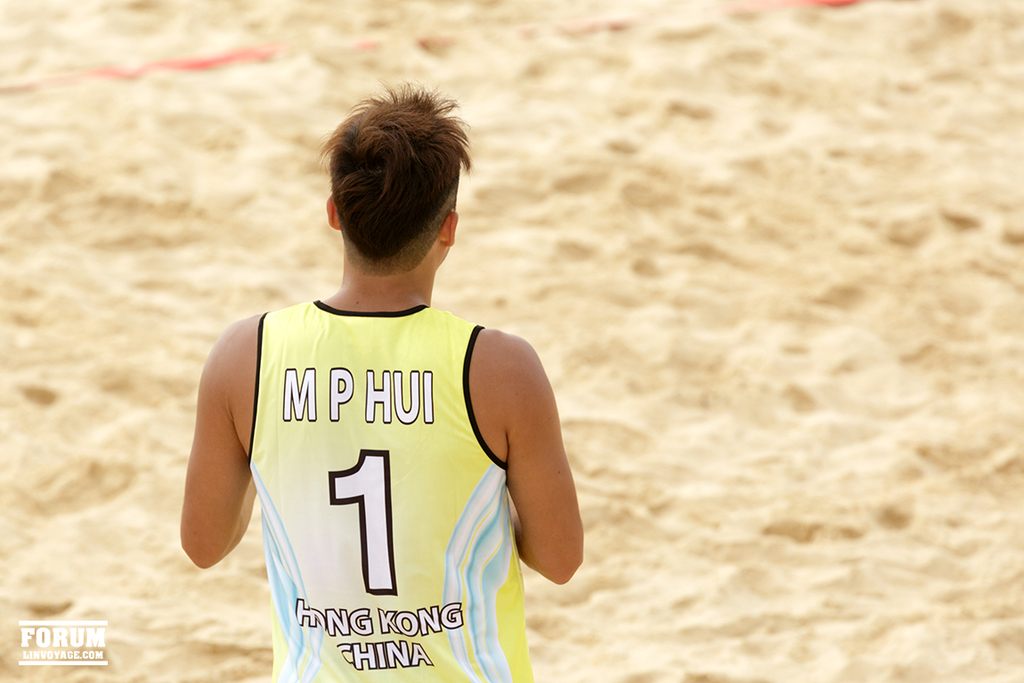Can you describe the environment surrounding the individual in this photo? The photo shows a sandy beach area, which is typically used for beach sports like volleyball. The unmarked boundary lines and absence of other players or objects provide a minimalist setting, focusing attention on the athlete and his sportswear. Is there anything interesting about the weather or lighting conditions in this image? The lighting in the image is bright and direct, likely indicative of a sunny day, which is ideal for beach activities. The shadows and light distribution suggest early morning or late afternoon, times preferred for sports to avoid the midday heat. 